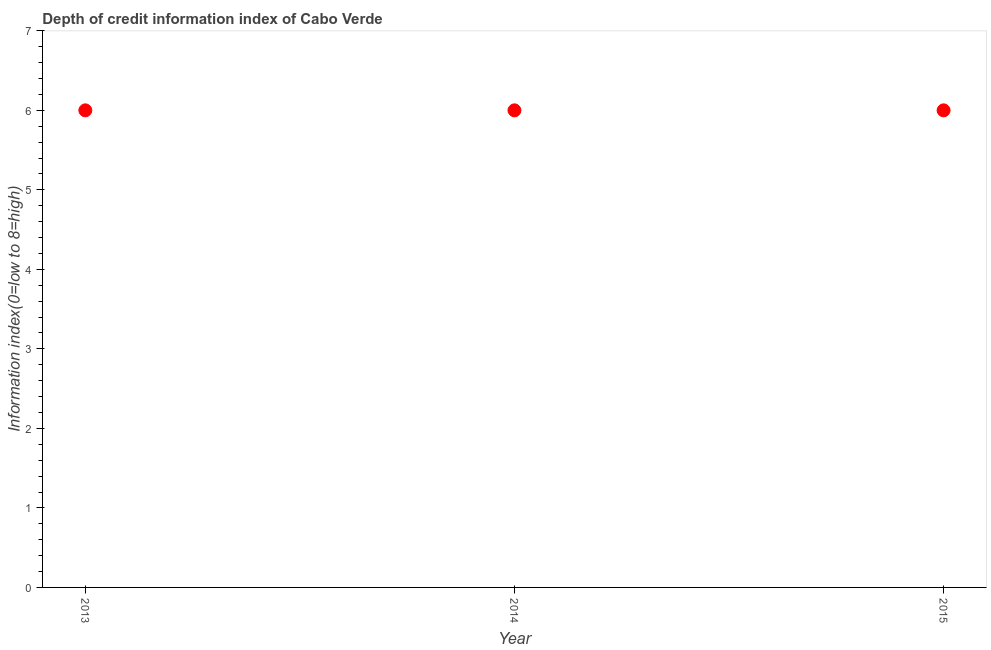What is the depth of credit information index in 2014?
Provide a short and direct response. 6. Across all years, what is the maximum depth of credit information index?
Your answer should be very brief. 6. What is the sum of the depth of credit information index?
Give a very brief answer. 18. What is the average depth of credit information index per year?
Keep it short and to the point. 6. What is the median depth of credit information index?
Your response must be concise. 6. What is the ratio of the depth of credit information index in 2014 to that in 2015?
Give a very brief answer. 1. Is the sum of the depth of credit information index in 2014 and 2015 greater than the maximum depth of credit information index across all years?
Your answer should be very brief. Yes. What is the difference between the highest and the lowest depth of credit information index?
Provide a succinct answer. 0. Does the depth of credit information index monotonically increase over the years?
Make the answer very short. No. How many dotlines are there?
Provide a succinct answer. 1. How many years are there in the graph?
Make the answer very short. 3. Does the graph contain grids?
Offer a terse response. No. What is the title of the graph?
Ensure brevity in your answer.  Depth of credit information index of Cabo Verde. What is the label or title of the X-axis?
Your answer should be compact. Year. What is the label or title of the Y-axis?
Your answer should be compact. Information index(0=low to 8=high). What is the Information index(0=low to 8=high) in 2014?
Your answer should be very brief. 6. What is the difference between the Information index(0=low to 8=high) in 2013 and 2014?
Provide a short and direct response. 0. What is the difference between the Information index(0=low to 8=high) in 2013 and 2015?
Your answer should be compact. 0. What is the ratio of the Information index(0=low to 8=high) in 2013 to that in 2014?
Offer a very short reply. 1. 